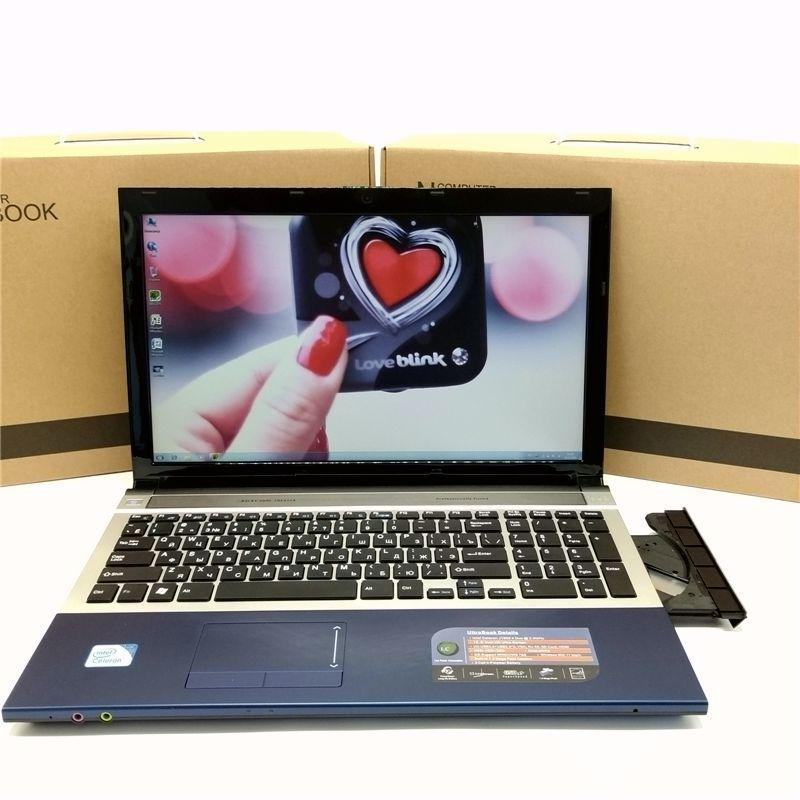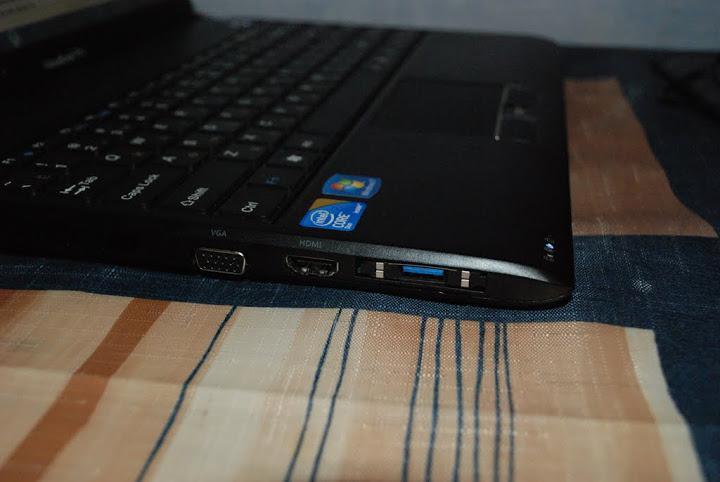The first image is the image on the left, the second image is the image on the right. Considering the images on both sides, is "At least one computer has a blue graphic background on the screen." valid? Answer yes or no. No. The first image is the image on the left, the second image is the image on the right. Examine the images to the left and right. Is the description "In one image, the laptop screen displays a created sweeping scene." accurate? Answer yes or no. No. 